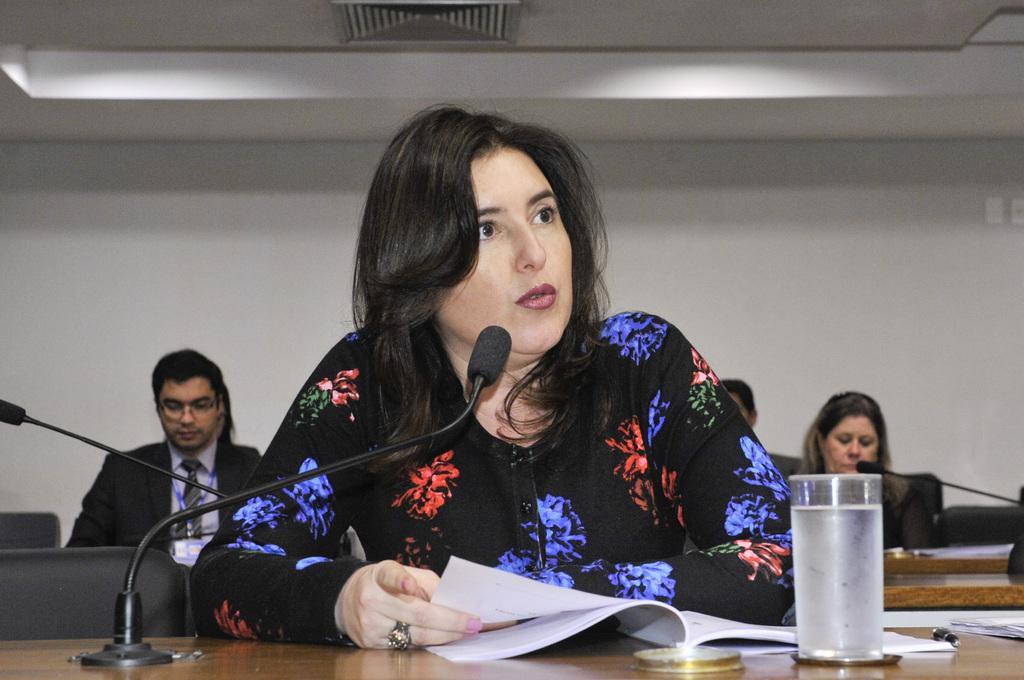Describe this image in one or two sentences. There is a Mic, papers and a glass is present on a wooden surface as we can see at the bottom of this image. There is one woman sitting and holding a paper is in the middle of this image. We can see other people in the background and there is a wall present behind these persons. 